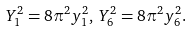Convert formula to latex. <formula><loc_0><loc_0><loc_500><loc_500>Y _ { 1 } ^ { 2 } = 8 \pi ^ { 2 } y _ { 1 } ^ { 2 } , \, Y _ { 6 } ^ { 2 } = 8 \pi ^ { 2 } y _ { 6 } ^ { 2 } .</formula> 